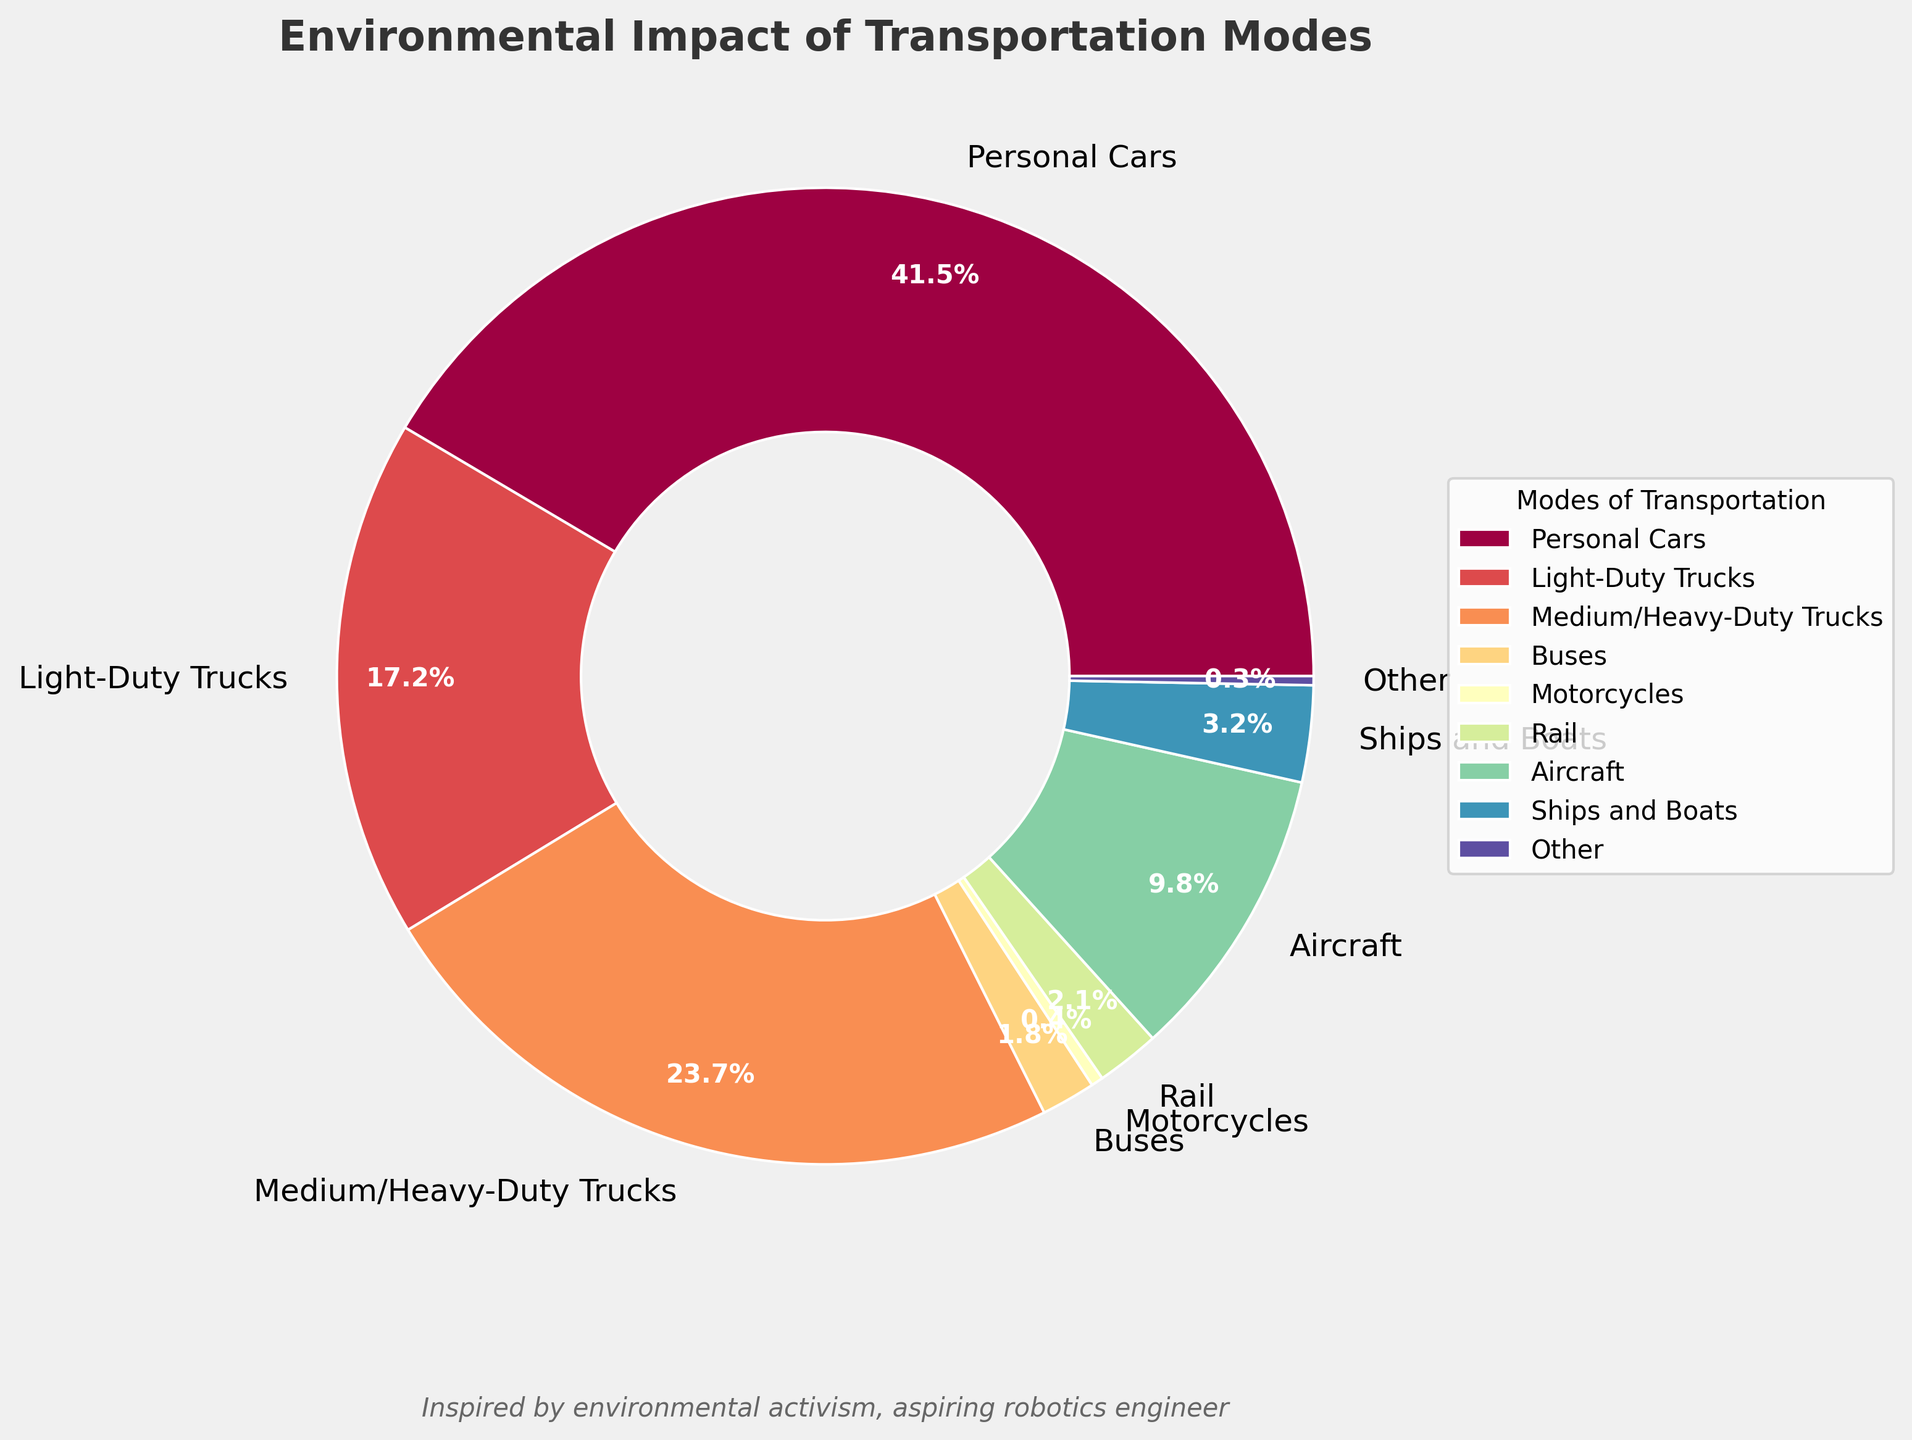What's the mode of transportation with the highest CO2 emissions? The figure shows that 'Personal Cars' have the largest segment in the pie chart, indicating they have the highest percentage of CO2 emissions.
Answer: Personal Cars Which mode of transportation has the least CO2 emissions? 'Other' occupies the smallest segment of the pie chart, indicating it has the lowest percentage of CO2 emissions.
Answer: Other What is the combined CO2 emissions percentage of Light-Duty Trucks and Medium/Heavy-Duty Trucks? Light-Duty Trucks have 17.2% and Medium/Heavy-Duty Trucks have 23.7%, adding them together gives 17.2 + 23.7 = 40.9%.
Answer: 40.9% Are aircraft emissions higher than rail emissions? The pie chart shows aircraft emissions are 9.8% and rail emissions are 2.1%. Since 9.8% is greater than 2.1%, aircraft emissions are higher than rail emissions.
Answer: Yes How does the CO2 emission from ships and boats compare to that of buses? Ships and Boats have 3.2% CO2 emissions and Buses have 1.8%. Since 3.2% is greater than 1.8%, Ships and Boats have higher CO2 emissions compared to Buses.
Answer: Ships and Boats have higher CO2 emissions What percentage of CO2 emissions is contributed by vehicles categorized under 'Motorcycles' and 'Other' combined? Motorcycles contribute 0.4% and Other contributes 0.3%. Adding them together gives 0.4 + 0.3 = 0.7%.
Answer: 0.7% Which two modes of transportation have CO2 emissions percentages closest to each other? Rails have 2.1% and Ships and Boats have 3.2%. The difference between them is 3.2 - 2.1 = 1.1%, which is smaller compared to differences between other pairs.
Answer: Rail and Ships and Boats What portion of the total CO2 emissions is accounted for by road transport (Personal Cars, Light-Duty Trucks, Medium/Heavy-Duty Trucks, and Buses)? Adding the contributions from Personal Cars (41.5%), Light-Duty Trucks (17.2%), Medium/Heavy-Duty Trucks (23.7%), and Buses (1.8%) gives the total as 41.5 + 17.2 + 23.7 + 1.8 = 84.2%.
Answer: 84.2% Is the contribution of CO2 emissions from aircraft more than double that of motorcycles? Aircraft emits 9.8% CO2 and Motorcycles emit 0.4%. Multiplying the motorcycle emissions by 2 gives 0.4 * 2 = 0.8%, which is much less than 9.8%.
Answer: Yes 